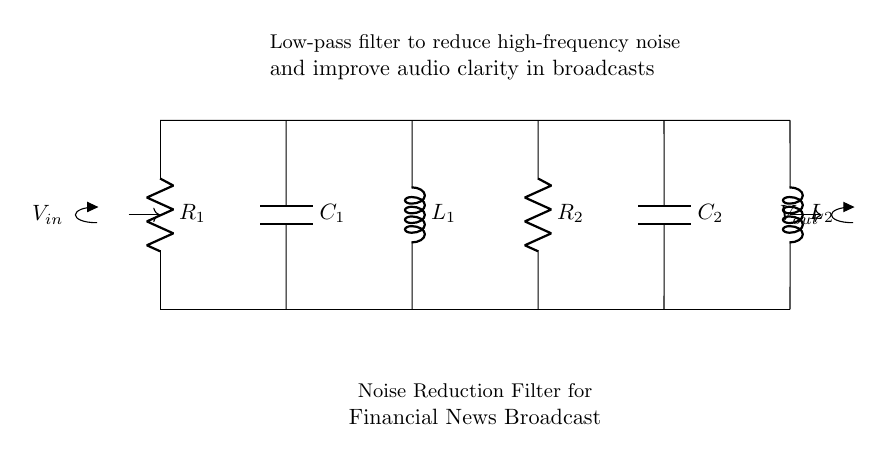What type of filter is represented in the diagram? The diagram illustrates a low-pass filter, identified by the arrangement of resistors, capacitors, and inductors, which allows low-frequency signals to pass while attenuating higher-frequency noise.
Answer: Low-pass filter What component is labeled R1? R1 is the first resistor in the circuit, positioned at the leftmost side, connecting the voltage input to the top line of the circuit.
Answer: Resistor How many capacitors are present in the circuit? The circuit contains two capacitors, identified as C1 and C2, which are located at the second and fifth positions from the left, respectively.
Answer: Two What is the primary purpose of this circuit? The primary purpose of this circuit is to reduce high-frequency noise that can interfere with audio quality during broadcasts, as described in the annotation on the diagram.
Answer: Noise reduction Which components are used for filtering in the circuit? The components used for filtering are the resistors, capacitors, and inductors, specifically R1, R2, C1, C2, L1, and L2, all working together to shape the frequency response of the filter.
Answer: Resistors, capacitors, inductors What is the function of L2 in this circuit? L2, the second inductor, serves to further enhance the low-pass filtering effect of the circuit by allowing low frequencies to pass while providing additional impedance to higher frequencies.
Answer: Low-pass filtering What happens to high-frequency noise in this circuit? High-frequency noise is attenuated or reduced as it passes through the filter, due to the combination of resistive, capacitive, and inductive elements designed for this specific purpose.
Answer: Attenuated 